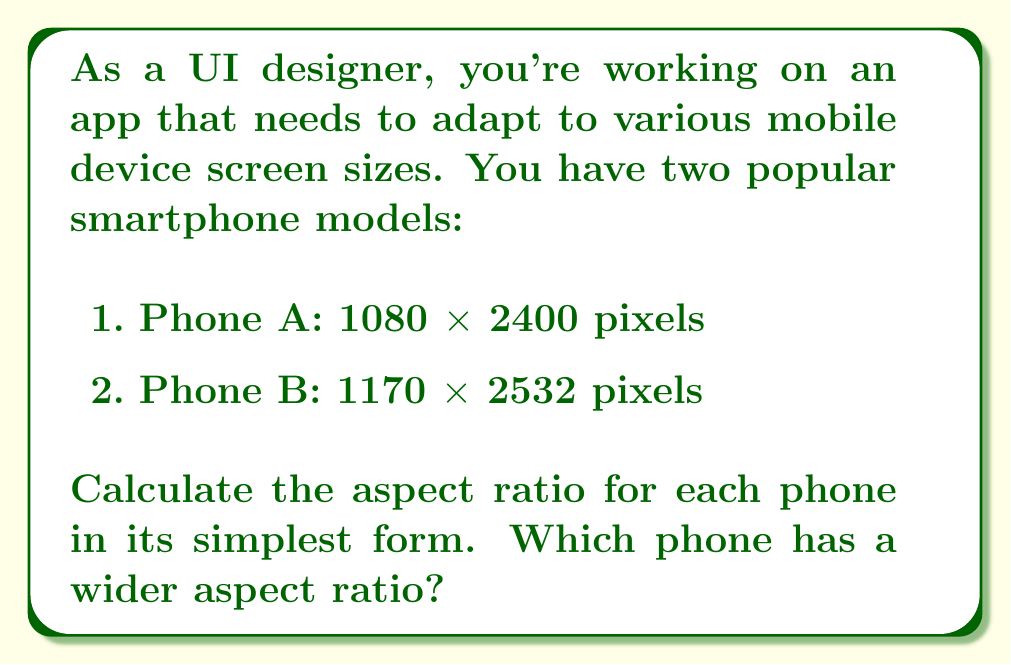Give your solution to this math problem. To calculate the aspect ratio, we need to compare the width to the height of each screen. The aspect ratio is typically expressed as width:height.

For Phone A:
1. Divide both dimensions by their greatest common divisor (GCD):
   $GCD(1080, 2400) = 120$
   $$\frac{1080}{120} : \frac{2400}{120} = 9 : 20$$

For Phone B:
1. Divide both dimensions by their greatest common divisor (GCD):
   $GCD(1170, 2532) = 18$
   $$\frac{1170}{18} : \frac{2532}{18} = 65 : 141$$

To compare the aspect ratios, we can convert them to decimals:

Phone A: $\frac{9}{20} = 0.45$
Phone B: $\frac{65}{141} \approx 0.4609$

A larger decimal value indicates a wider aspect ratio.
Answer: Phone A aspect ratio: 9:20
Phone B aspect ratio: 65:141
Phone B has a wider aspect ratio. 